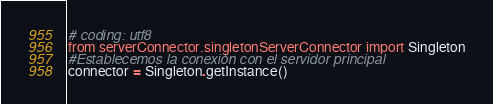Convert code to text. <code><loc_0><loc_0><loc_500><loc_500><_Python_># coding: utf8
from serverConnector.singletonServerConnector import Singleton
#Establecemos la conexión con el servidor principal
connector = Singleton.getInstance()
</code> 